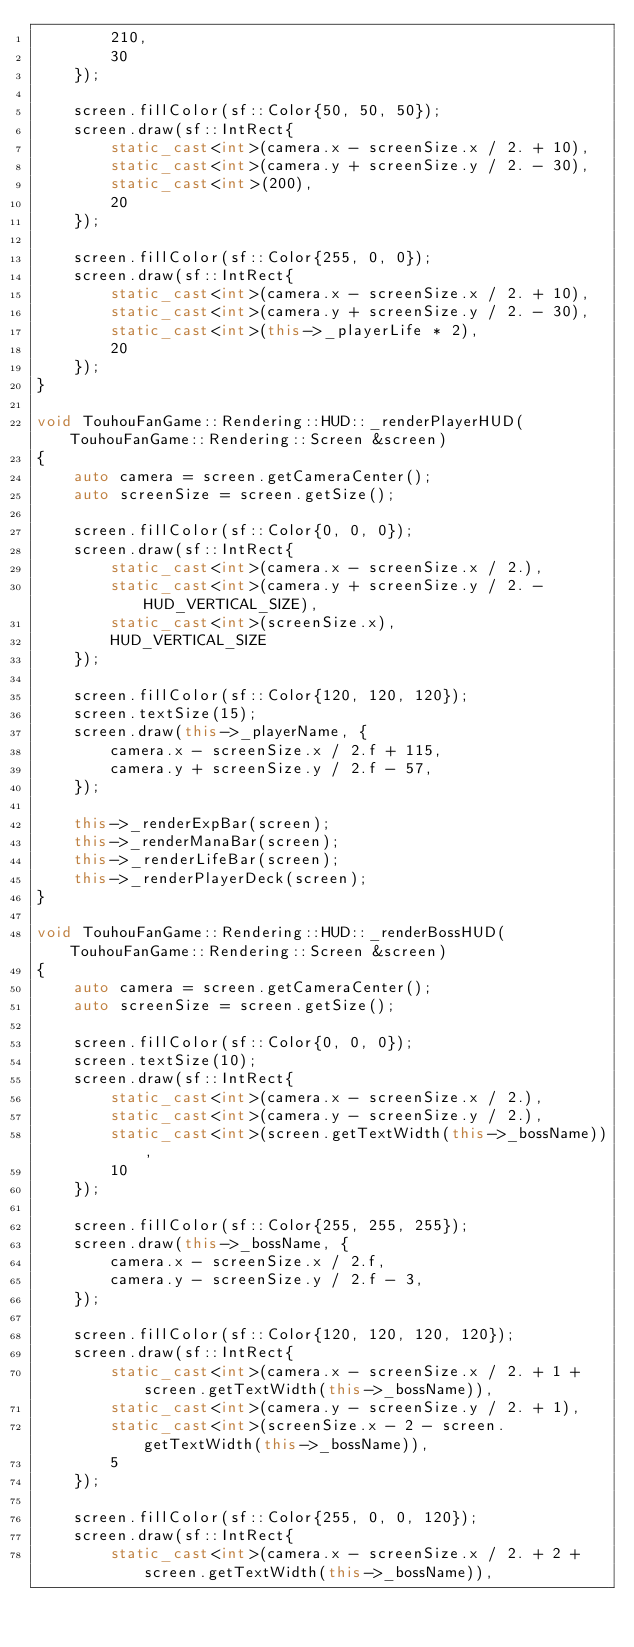<code> <loc_0><loc_0><loc_500><loc_500><_C++_>		210,
		30
	});

	screen.fillColor(sf::Color{50, 50, 50});
	screen.draw(sf::IntRect{
		static_cast<int>(camera.x - screenSize.x / 2. + 10),
		static_cast<int>(camera.y + screenSize.y / 2. - 30),
		static_cast<int>(200),
		20
	});

	screen.fillColor(sf::Color{255, 0, 0});
	screen.draw(sf::IntRect{
		static_cast<int>(camera.x - screenSize.x / 2. + 10),
		static_cast<int>(camera.y + screenSize.y / 2. - 30),
		static_cast<int>(this->_playerLife * 2),
		20
	});
}

void TouhouFanGame::Rendering::HUD::_renderPlayerHUD(TouhouFanGame::Rendering::Screen &screen)
{
	auto camera = screen.getCameraCenter();
	auto screenSize = screen.getSize();

	screen.fillColor(sf::Color{0, 0, 0});
	screen.draw(sf::IntRect{
		static_cast<int>(camera.x - screenSize.x / 2.),
		static_cast<int>(camera.y + screenSize.y / 2. - HUD_VERTICAL_SIZE),
		static_cast<int>(screenSize.x),
		HUD_VERTICAL_SIZE
	});

	screen.fillColor(sf::Color{120, 120, 120});
	screen.textSize(15);
	screen.draw(this->_playerName, {
		camera.x - screenSize.x / 2.f + 115,
		camera.y + screenSize.y / 2.f - 57,
	});

	this->_renderExpBar(screen);
	this->_renderManaBar(screen);
	this->_renderLifeBar(screen);
	this->_renderPlayerDeck(screen);
}

void TouhouFanGame::Rendering::HUD::_renderBossHUD(TouhouFanGame::Rendering::Screen &screen)
{
	auto camera = screen.getCameraCenter();
	auto screenSize = screen.getSize();

	screen.fillColor(sf::Color{0, 0, 0});
	screen.textSize(10);
	screen.draw(sf::IntRect{
		static_cast<int>(camera.x - screenSize.x / 2.),
		static_cast<int>(camera.y - screenSize.y / 2.),
		static_cast<int>(screen.getTextWidth(this->_bossName)),
		10
	});

	screen.fillColor(sf::Color{255, 255, 255});
	screen.draw(this->_bossName, {
		camera.x - screenSize.x / 2.f,
		camera.y - screenSize.y / 2.f - 3,
	});

	screen.fillColor(sf::Color{120, 120, 120, 120});
	screen.draw(sf::IntRect{
		static_cast<int>(camera.x - screenSize.x / 2. + 1 + screen.getTextWidth(this->_bossName)),
		static_cast<int>(camera.y - screenSize.y / 2. + 1),
		static_cast<int>(screenSize.x - 2 - screen.getTextWidth(this->_bossName)),
		5
	});

	screen.fillColor(sf::Color{255, 0, 0, 120});
	screen.draw(sf::IntRect{
		static_cast<int>(camera.x - screenSize.x / 2. + 2 + screen.getTextWidth(this->_bossName)),</code> 